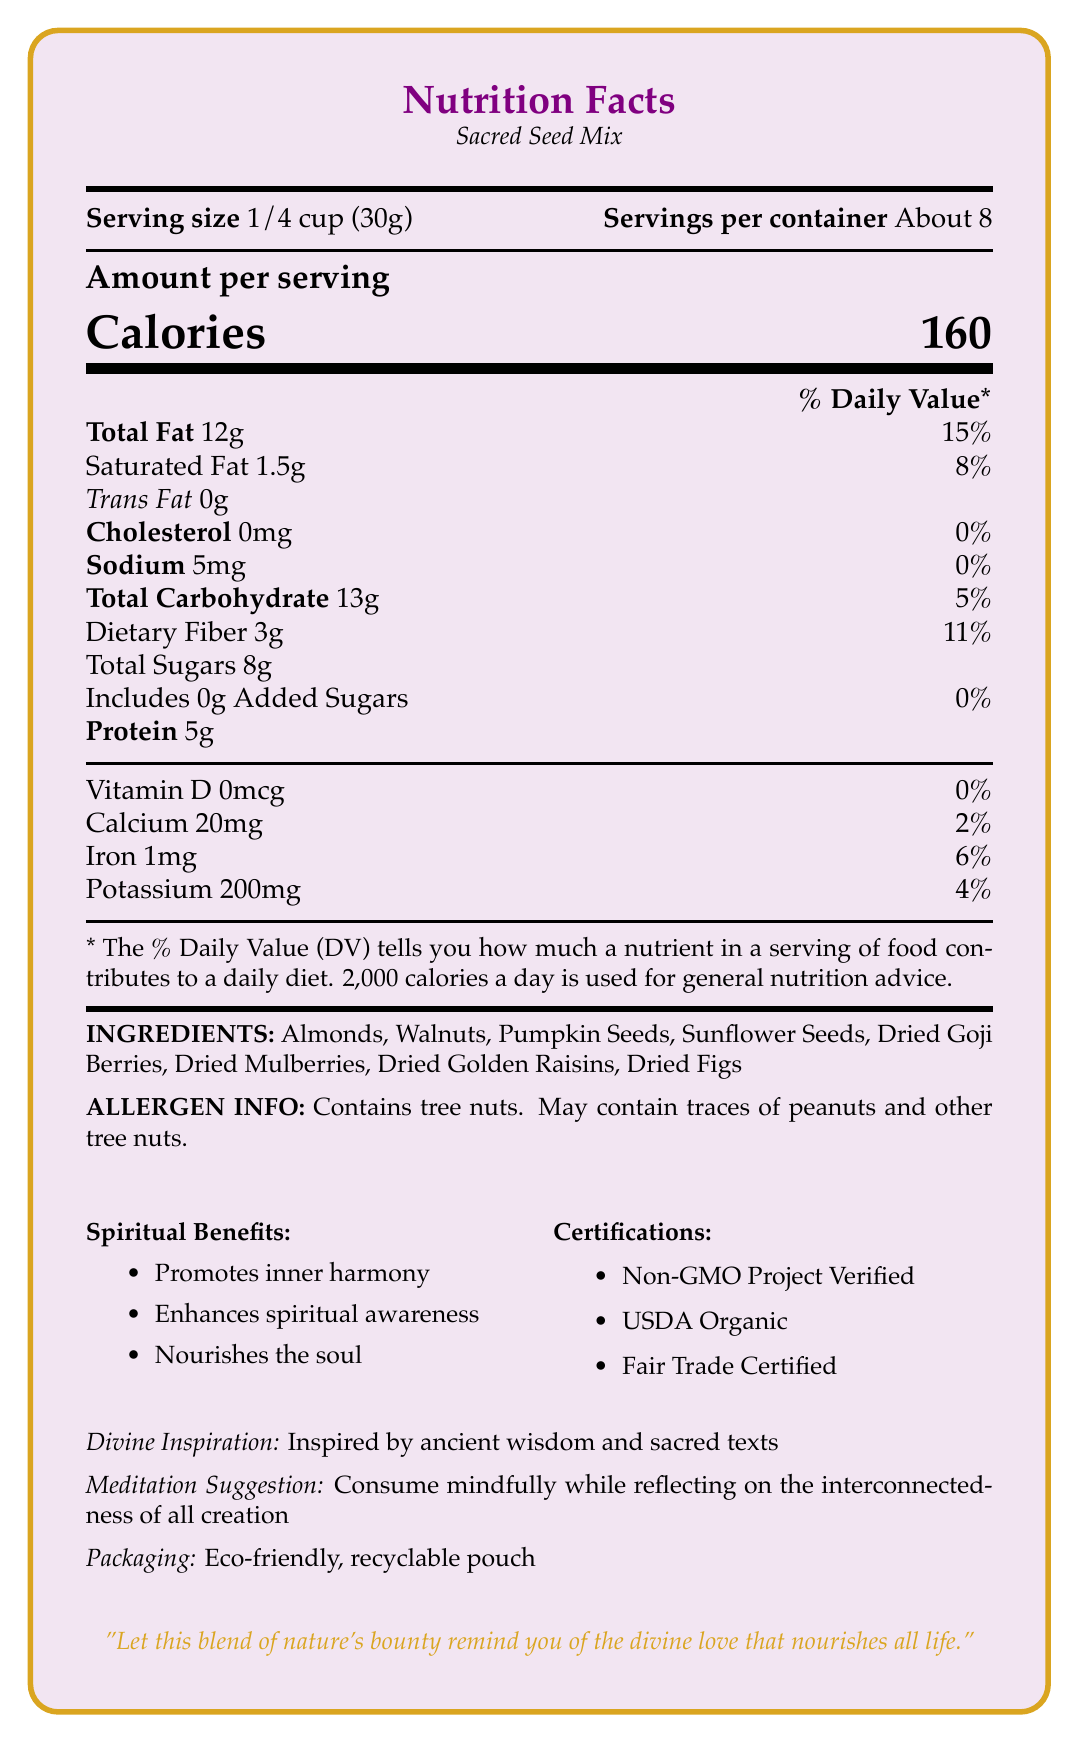what is the serving size? The serving size is clearly mentioned as "1/4 cup (30g)" in the document.
Answer: 1/4 cup (30g) how many servings are in the container? The servings per container are listed as "About 8."
Answer: About 8 how many calories are in one serving of Sacred Seed Mix? The document states that each serving contains 160 calories.
Answer: 160 what is the amount of total fat per serving? The total fat per serving is specified as 12g.
Answer: 12g what are the main ingredients in Sacred Seed Mix? The ingredients are listed as Almonds, Walnuts, Pumpkin Seeds, Sunflower Seeds, Dried Goji Berries, Dried Mulberries, Dried Golden Raisins, and Dried Figs.
Answer: Almonds, Walnuts, Pumpkin Seeds, Sunflower Seeds, Dried Goji Berries, Dried Mulberries, Dried Golden Raisins, Dried Figs which of the following is a spiritual benefit of consuming Sacred Seed Mix? A. Boosts physical stamina B. Promotes inner harmony C. Improves digestion D. Enhances physical strength The document lists "Promotes inner harmony" as one of the spiritual benefits.
Answer: B what is the percentage daily value of dietary fiber in one serving? A. 5% B. 8% C. 11% D. 15% The percentage daily value of dietary fiber in one serving is 11%, as stated in the document.
Answer: C is the packaging of Sacred Seed Mix eco-friendly? The document indicates that the packaging is "Eco-friendly, recyclable pouch."
Answer: Yes describe the main idea of the document. The document gives a comprehensive overview of the Sacred Seed Mix, focusing on both its nutritional and spiritual aspects. It specifies the serving size, nutritional content, ingredients, and allergen information. It also emphasizes the spiritual benefits, certifications, and eco-friendly packaging, along with a meditation suggestion and a devotional quote.
Answer: The document provides detailed nutritional information about the Sacred Seed Mix, including serving size, calorie content, and the amounts of various nutrients. It also highlights the ingredients, allergen information, spiritual benefits, certifications, and packaging information. Additionally, it includes a meditation suggestion and a devotional quote. can this product help increase calcium intake significantly? The document states that each serving provides only 2% of the daily value for calcium, which is not a significant amount.
Answer: No what inspired the creation of Sacred Seed Mix? The document mentions that the product is "Inspired by ancient wisdom and sacred texts."
Answer: Ancient wisdom and sacred texts how much protein is in each serving? The document states that there are 5g of protein per serving.
Answer: 5g is Sacred Seed Mix certified as Fair Trade? The document lists "Fair Trade Certified" under certifications.
Answer: Yes what percentage of the daily value for iron does one serving provide? The iron content per serving is listed as 1mg, which is 6% of the daily value.
Answer: 6% which certification is not mentioned in the document? A. Non-GMO Project Verified B. USDA Organic C. Gluten-Free Certified D. Fair Trade Certified The document mentions Non-GMO Project Verified, USDA Organic, and Fair Trade Certified, but does not mention Gluten-Free Certified.
Answer: C what are the suggested meditative practices while consuming this product? The document suggests consuming the product mindfully while reflecting on the interconnectedness of all creation.
Answer: Reflect on the interconnectedness of all creation what is the total carbohydrate content per serving? The total carbohydrate content per serving is listed as 13g.
Answer: 13g how much-added sugars does Sacred Seed Mix contain per serving? The document states that there are 0g of added sugars per serving.
Answer: 0g how is the quote on the document meant to reflect the product's philosophy? The quote: "Let this blend of nature's bounty remind you of the divine love that nourishes all life," emphasizes the divine and nurturing qualities intended to be conveyed through the product.
Answer: It reflects the importance of divine love and nature’s bounty nourishing all life. how many calories are from fat in each serving? The document does not provide explicit information on the number of calories derived from fat in each serving.
Answer: Cannot be determined 